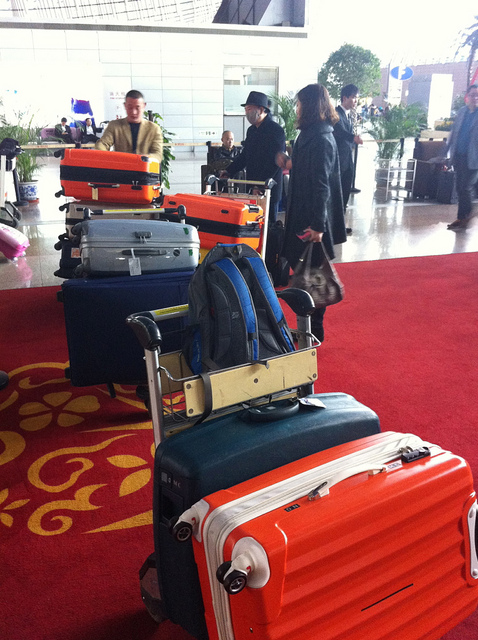How many umbrellas are in the photo? 0 